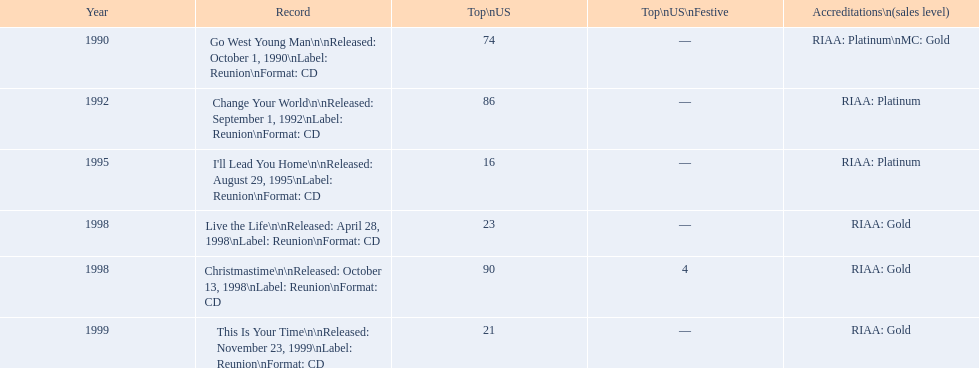Which michael w smith album had the highest ranking on the us chart? I'll Lead You Home. 